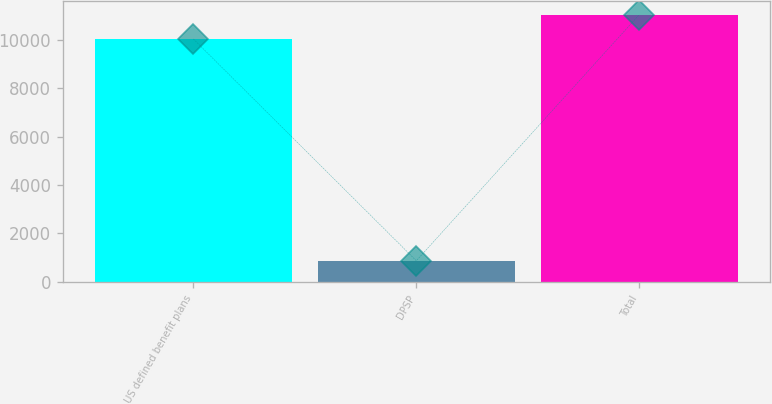Convert chart to OTSL. <chart><loc_0><loc_0><loc_500><loc_500><bar_chart><fcel>US defined benefit plans<fcel>DPSP<fcel>Total<nl><fcel>10034<fcel>872<fcel>11037.4<nl></chart> 